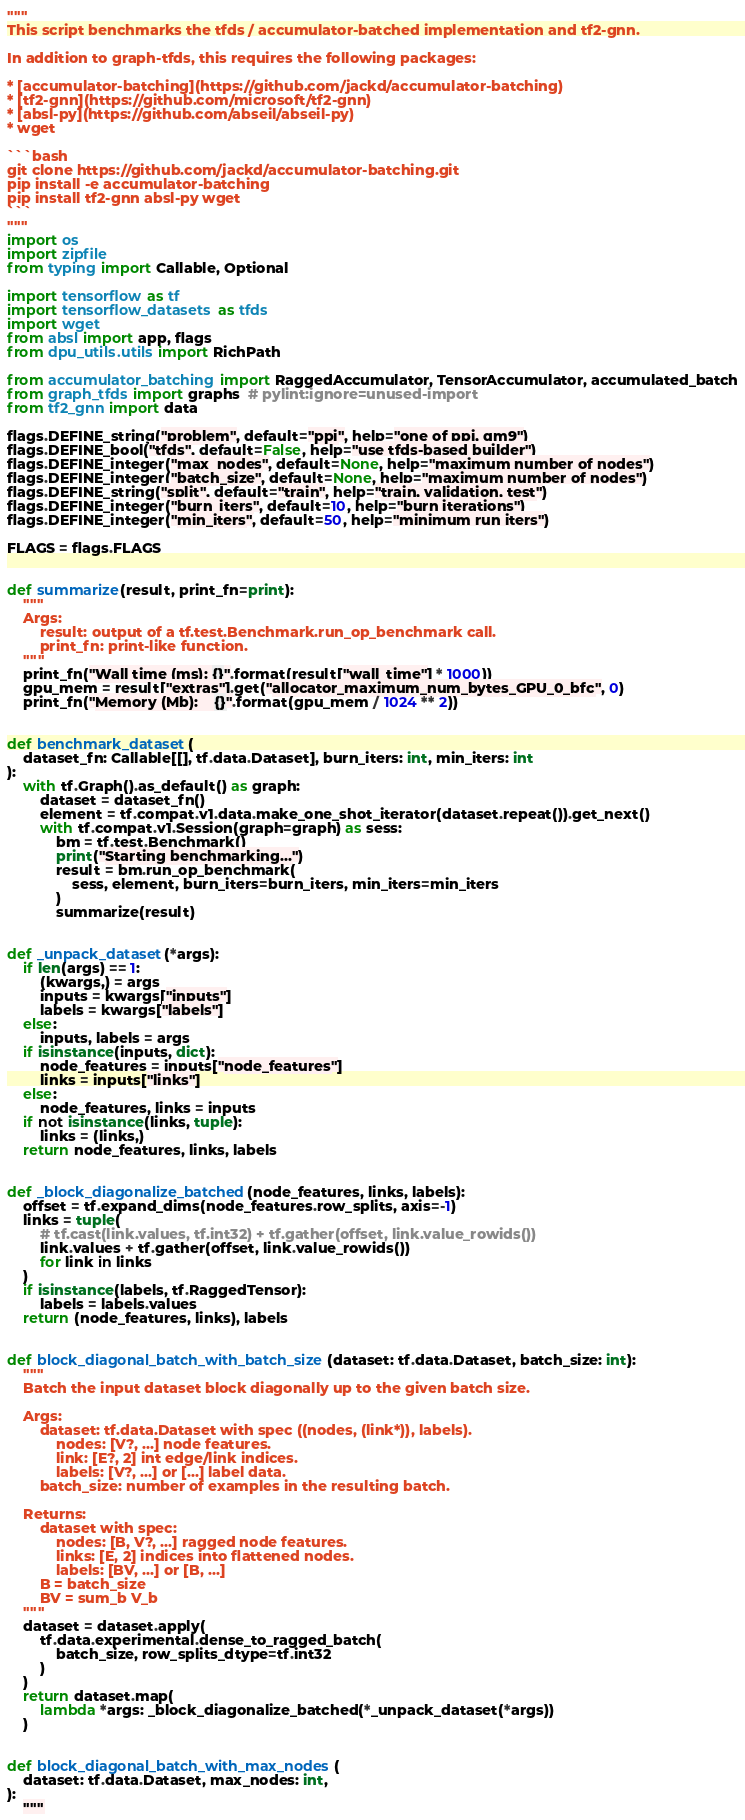Convert code to text. <code><loc_0><loc_0><loc_500><loc_500><_Python_>"""
This script benchmarks the tfds / accumulator-batched implementation and tf2-gnn.

In addition to graph-tfds, this requires the following packages:

* [accumulator-batching](https://github.com/jackd/accumulator-batching)
* [tf2-gnn](https://github.com/microsoft/tf2-gnn)
* [absl-py](https://github.com/abseil/abseil-py)
* wget

```bash
git clone https://github.com/jackd/accumulator-batching.git
pip install -e accumulator-batching
pip install tf2-gnn absl-py wget
```
"""
import os
import zipfile
from typing import Callable, Optional

import tensorflow as tf
import tensorflow_datasets as tfds
import wget
from absl import app, flags
from dpu_utils.utils import RichPath

from accumulator_batching import RaggedAccumulator, TensorAccumulator, accumulated_batch
from graph_tfds import graphs  # pylint:ignore=unused-import
from tf2_gnn import data

flags.DEFINE_string("problem", default="ppi", help="one of ppi, qm9")
flags.DEFINE_bool("tfds", default=False, help="use tfds-based builder")
flags.DEFINE_integer("max_nodes", default=None, help="maximum number of nodes")
flags.DEFINE_integer("batch_size", default=None, help="maximum number of nodes")
flags.DEFINE_string("split", default="train", help="train, validation, test")
flags.DEFINE_integer("burn_iters", default=10, help="burn iterations")
flags.DEFINE_integer("min_iters", default=50, help="minimum run iters")

FLAGS = flags.FLAGS


def summarize(result, print_fn=print):
    """
    Args:
        result: output of a tf.test.Benchmark.run_op_benchmark call.
        print_fn: print-like function.
    """
    print_fn("Wall time (ms): {}".format(result["wall_time"] * 1000))
    gpu_mem = result["extras"].get("allocator_maximum_num_bytes_GPU_0_bfc", 0)
    print_fn("Memory (Mb):    {}".format(gpu_mem / 1024 ** 2))


def benchmark_dataset(
    dataset_fn: Callable[[], tf.data.Dataset], burn_iters: int, min_iters: int
):
    with tf.Graph().as_default() as graph:
        dataset = dataset_fn()
        element = tf.compat.v1.data.make_one_shot_iterator(dataset.repeat()).get_next()
        with tf.compat.v1.Session(graph=graph) as sess:
            bm = tf.test.Benchmark()
            print("Starting benchmarking...")
            result = bm.run_op_benchmark(
                sess, element, burn_iters=burn_iters, min_iters=min_iters
            )
            summarize(result)


def _unpack_dataset(*args):
    if len(args) == 1:
        (kwargs,) = args
        inputs = kwargs["inputs"]
        labels = kwargs["labels"]
    else:
        inputs, labels = args
    if isinstance(inputs, dict):
        node_features = inputs["node_features"]
        links = inputs["links"]
    else:
        node_features, links = inputs
    if not isinstance(links, tuple):
        links = (links,)
    return node_features, links, labels


def _block_diagonalize_batched(node_features, links, labels):
    offset = tf.expand_dims(node_features.row_splits, axis=-1)
    links = tuple(
        # tf.cast(link.values, tf.int32) + tf.gather(offset, link.value_rowids())
        link.values + tf.gather(offset, link.value_rowids())
        for link in links
    )
    if isinstance(labels, tf.RaggedTensor):
        labels = labels.values
    return (node_features, links), labels


def block_diagonal_batch_with_batch_size(dataset: tf.data.Dataset, batch_size: int):
    """
    Batch the input dataset block diagonally up to the given batch size.

    Args:
        dataset: tf.data.Dataset with spec ((nodes, (link*)), labels).
            nodes: [V?, ...] node features.
            link: [E?, 2] int edge/link indices.
            labels: [V?, ...] or [...] label data.
        batch_size: number of examples in the resulting batch.

    Returns:
        dataset with spec:
            nodes: [B, V?, ...] ragged node features.
            links: [E, 2] indices into flattened nodes.
            labels: [BV, ...] or [B, ...]
        B = batch_size
        BV = sum_b V_b
    """
    dataset = dataset.apply(
        tf.data.experimental.dense_to_ragged_batch(
            batch_size, row_splits_dtype=tf.int32
        )
    )
    return dataset.map(
        lambda *args: _block_diagonalize_batched(*_unpack_dataset(*args))
    )


def block_diagonal_batch_with_max_nodes(
    dataset: tf.data.Dataset, max_nodes: int,
):
    """</code> 